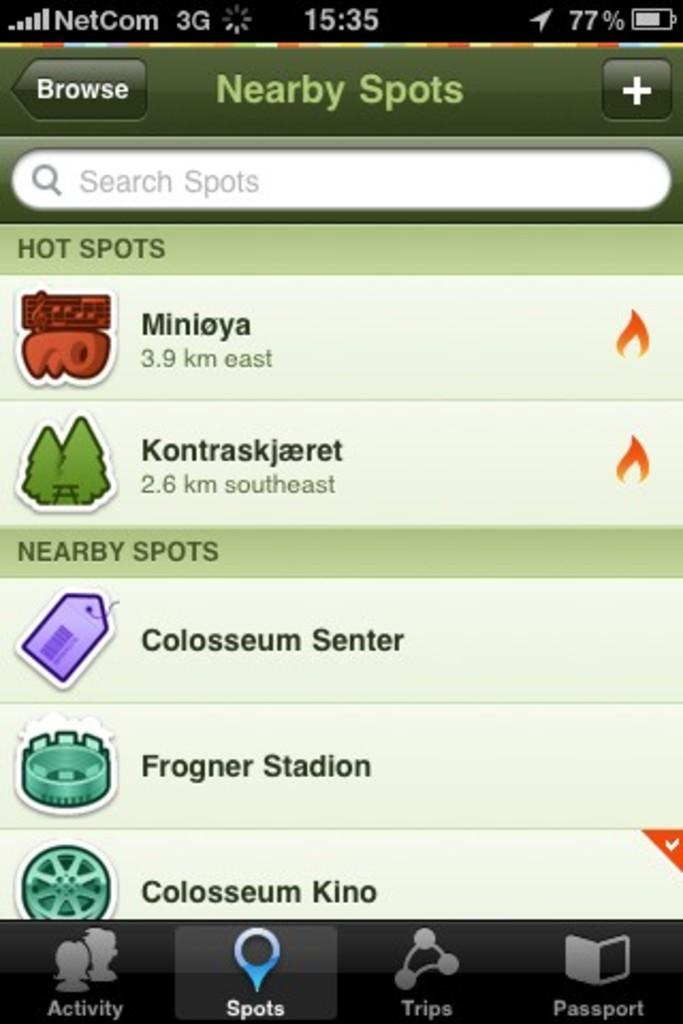<image>
Offer a succinct explanation of the picture presented. A screenshot of a cell phone displaying nearby spots. 